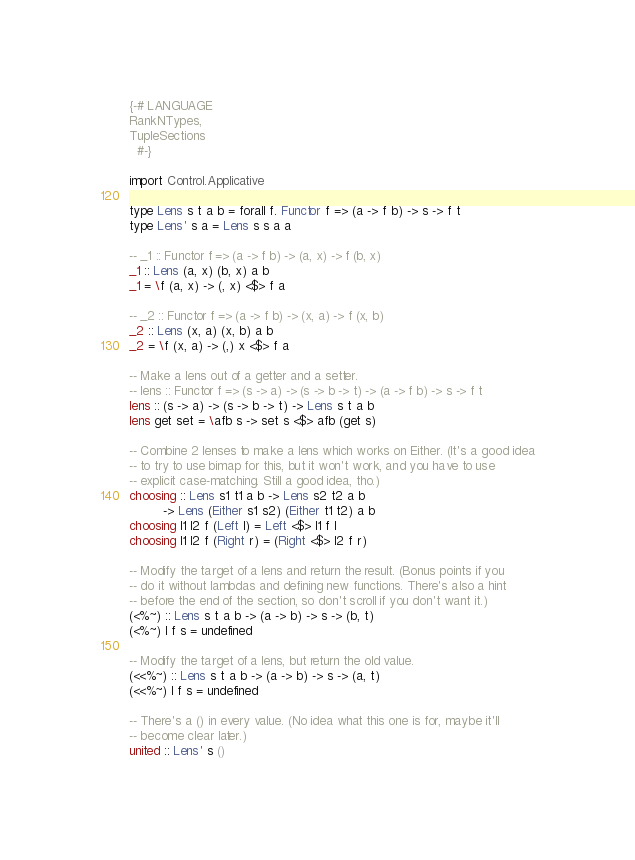<code> <loc_0><loc_0><loc_500><loc_500><_Haskell_>{-# LANGUAGE
RankNTypes,
TupleSections
  #-}

import Control.Applicative

type Lens s t a b = forall f. Functor f => (a -> f b) -> s -> f t
type Lens' s a = Lens s s a a

-- _1 :: Functor f => (a -> f b) -> (a, x) -> f (b, x)
_1 :: Lens (a, x) (b, x) a b
_1 = \f (a, x) -> (, x) <$> f a

-- _2 :: Functor f => (a -> f b) -> (x, a) -> f (x, b)
_2 :: Lens (x, a) (x, b) a b
_2 = \f (x, a) -> (,) x <$> f a

-- Make a lens out of a getter and a setter.
-- lens :: Functor f => (s -> a) -> (s -> b -> t) -> (a -> f b) -> s -> f t
lens :: (s -> a) -> (s -> b -> t) -> Lens s t a b
lens get set = \afb s -> set s <$> afb (get s)

-- Combine 2 lenses to make a lens which works on Either. (It's a good idea
-- to try to use bimap for this, but it won't work, and you have to use
-- explicit case-matching. Still a good idea, tho.)
choosing :: Lens s1 t1 a b -> Lens s2 t2 a b
         -> Lens (Either s1 s2) (Either t1 t2) a b
choosing l1 l2 f (Left l) = Left <$> l1 f l
choosing l1 l2 f (Right r) = (Right <$> l2 f r)

-- Modify the target of a lens and return the result. (Bonus points if you
-- do it without lambdas and defining new functions. There's also a hint
-- before the end of the section, so don't scroll if you don't want it.)
(<%~) :: Lens s t a b -> (a -> b) -> s -> (b, t)
(<%~) l f s = undefined

-- Modify the target of a lens, but return the old value.
(<<%~) :: Lens s t a b -> (a -> b) -> s -> (a, t)
(<<%~) l f s = undefined

-- There's a () in every value. (No idea what this one is for, maybe it'll
-- become clear later.)
united :: Lens' s ()</code> 